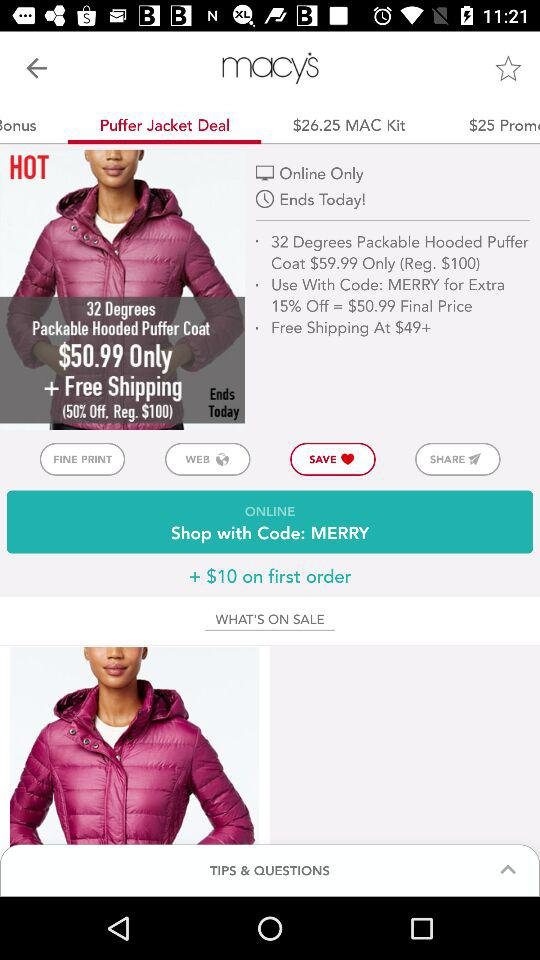How much is the puffer jacket on sale for?
Answer the question using a single word or phrase. $50.99 